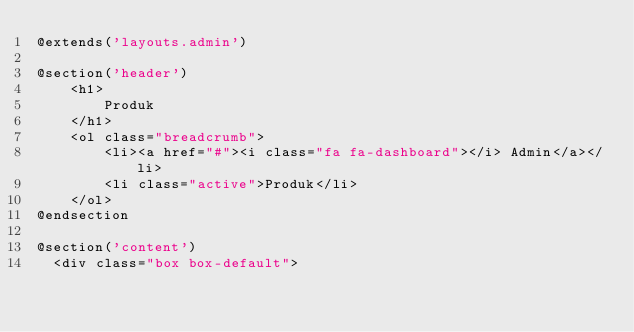Convert code to text. <code><loc_0><loc_0><loc_500><loc_500><_PHP_>@extends('layouts.admin')

@section('header')
    <h1>
        Produk
    </h1>
    <ol class="breadcrumb">
        <li><a href="#"><i class="fa fa-dashboard"></i> Admin</a></li>
        <li class="active">Produk</li>
    </ol>
@endsection

@section('content')
	<div class="box box-default"></code> 